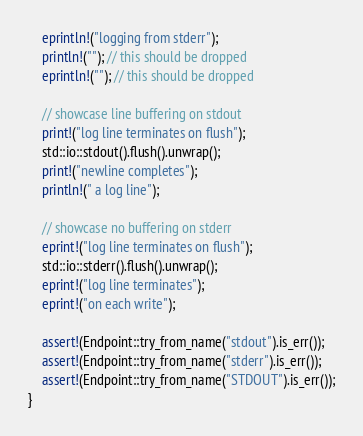<code> <loc_0><loc_0><loc_500><loc_500><_Rust_>    eprintln!("logging from stderr");
    println!(""); // this should be dropped
    eprintln!(""); // this should be dropped

    // showcase line buffering on stdout
    print!("log line terminates on flush");
    std::io::stdout().flush().unwrap();
    print!("newline completes");
    println!(" a log line");

    // showcase no buffering on stderr
    eprint!("log line terminates on flush");
    std::io::stderr().flush().unwrap();
    eprint!("log line terminates");
    eprint!("on each write");

    assert!(Endpoint::try_from_name("stdout").is_err());
    assert!(Endpoint::try_from_name("stderr").is_err());
    assert!(Endpoint::try_from_name("STDOUT").is_err());
}
</code> 